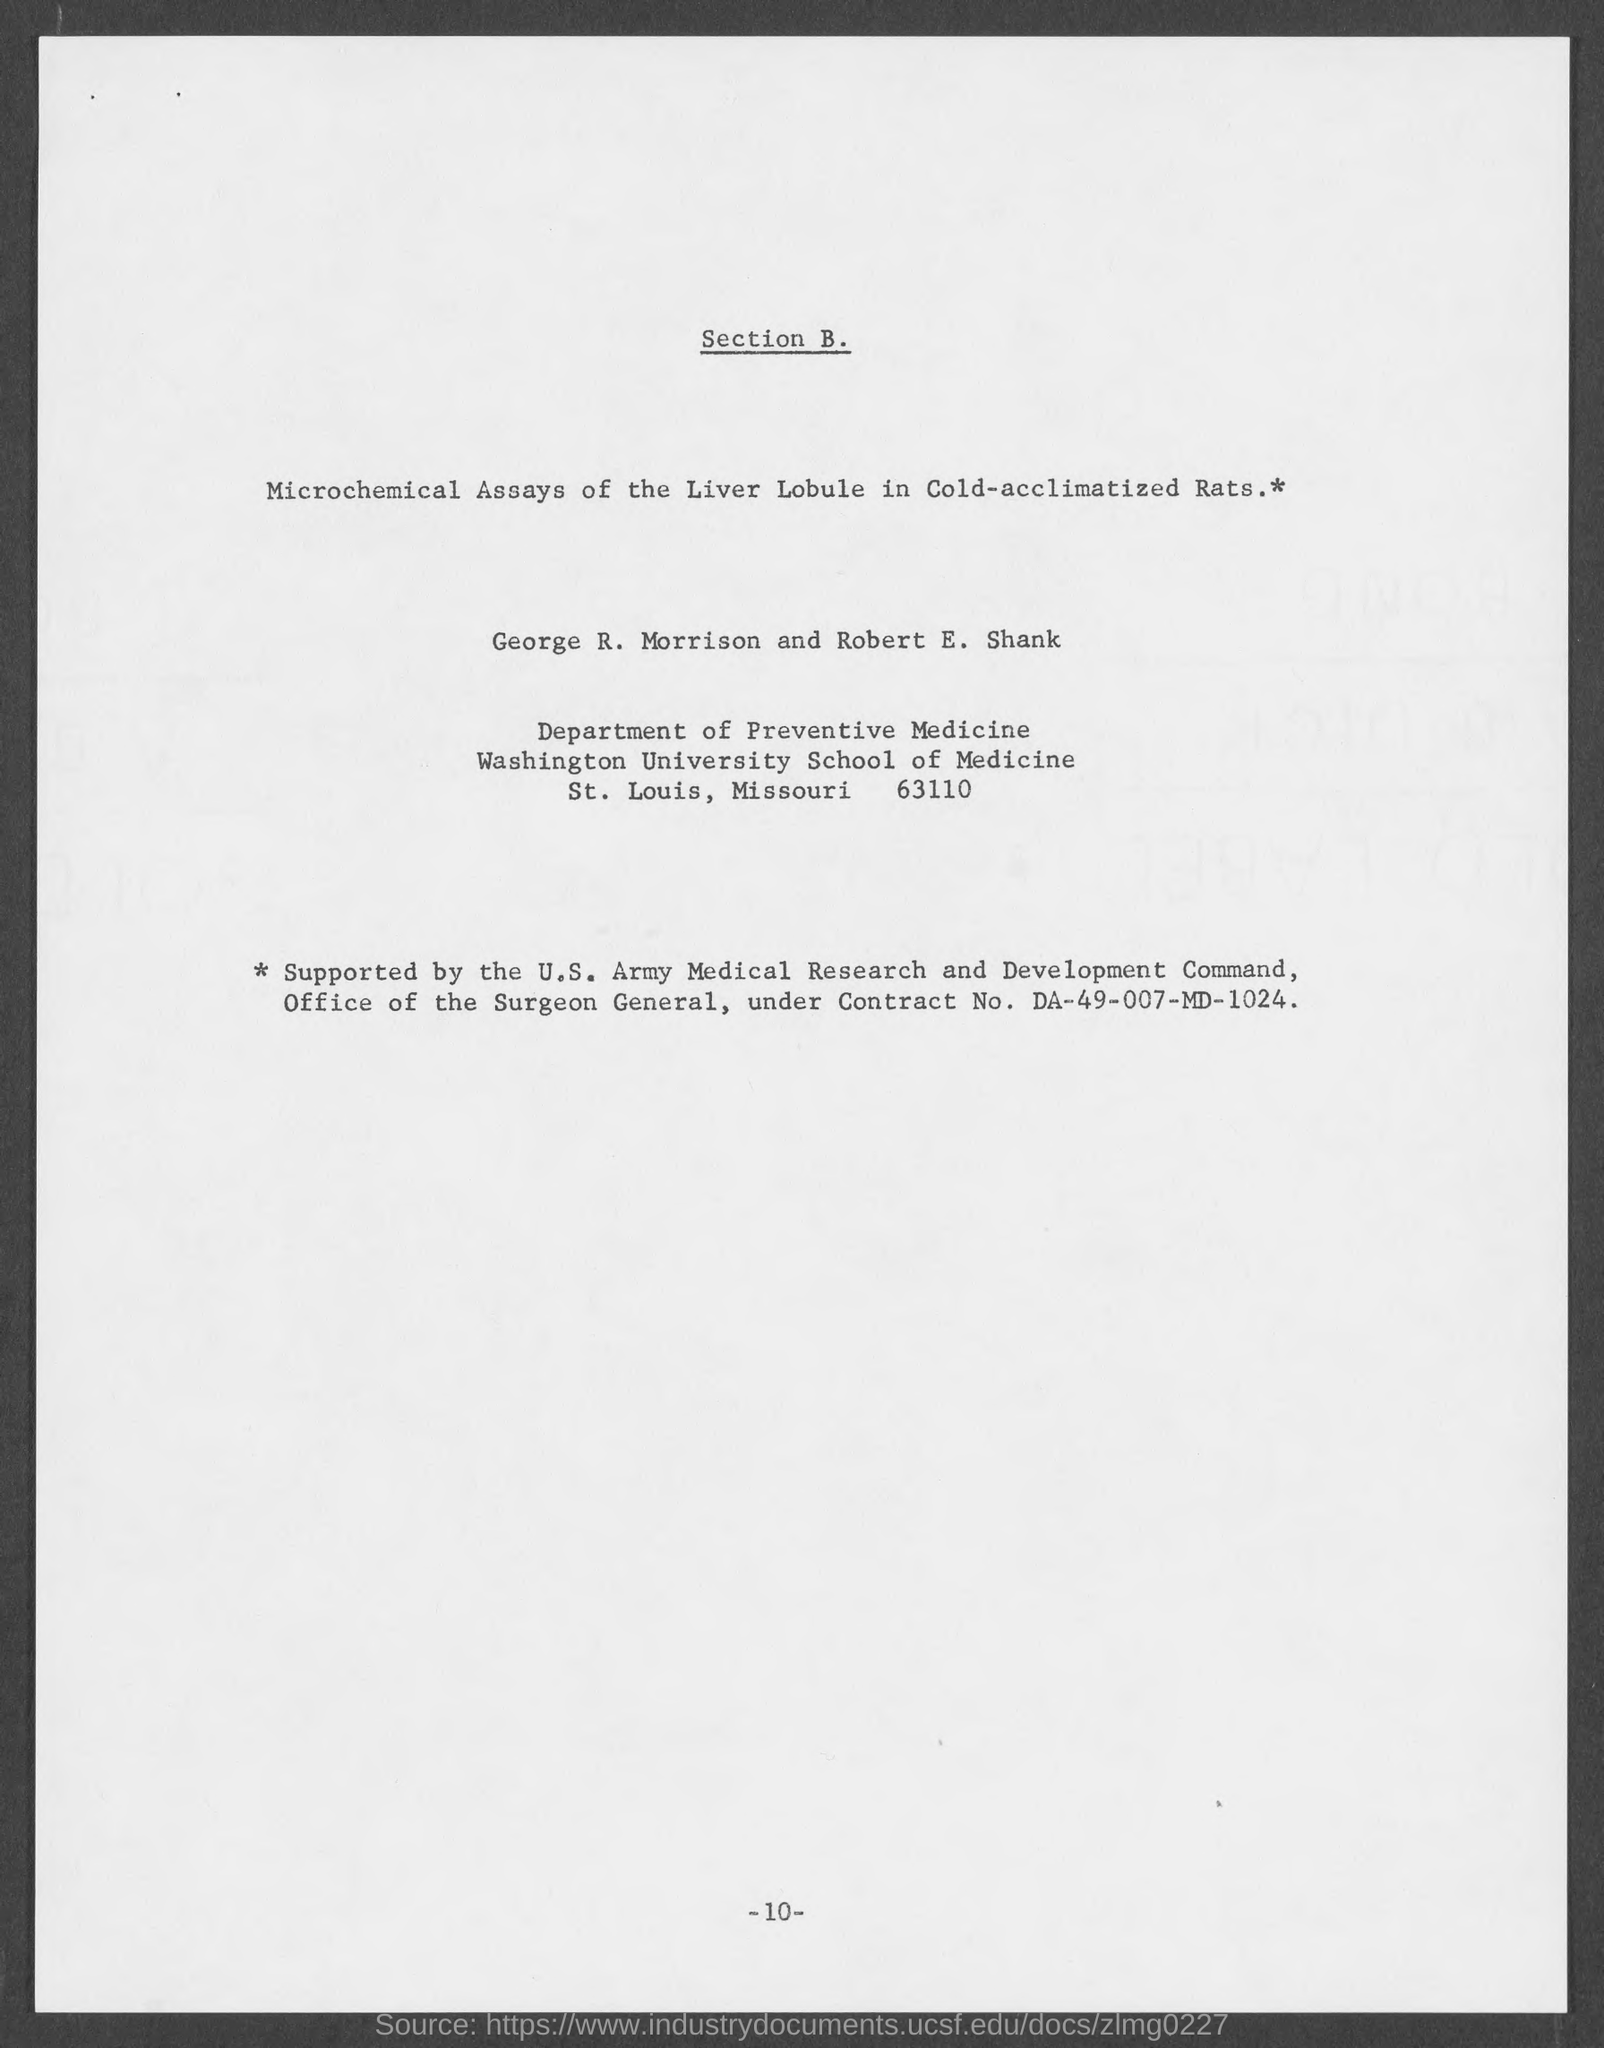What is Contract No.?
Keep it short and to the point. DA-49-007-MD-1024. What is the department mentioned in the document?
Provide a short and direct response. Department of Preventive Medicine. 